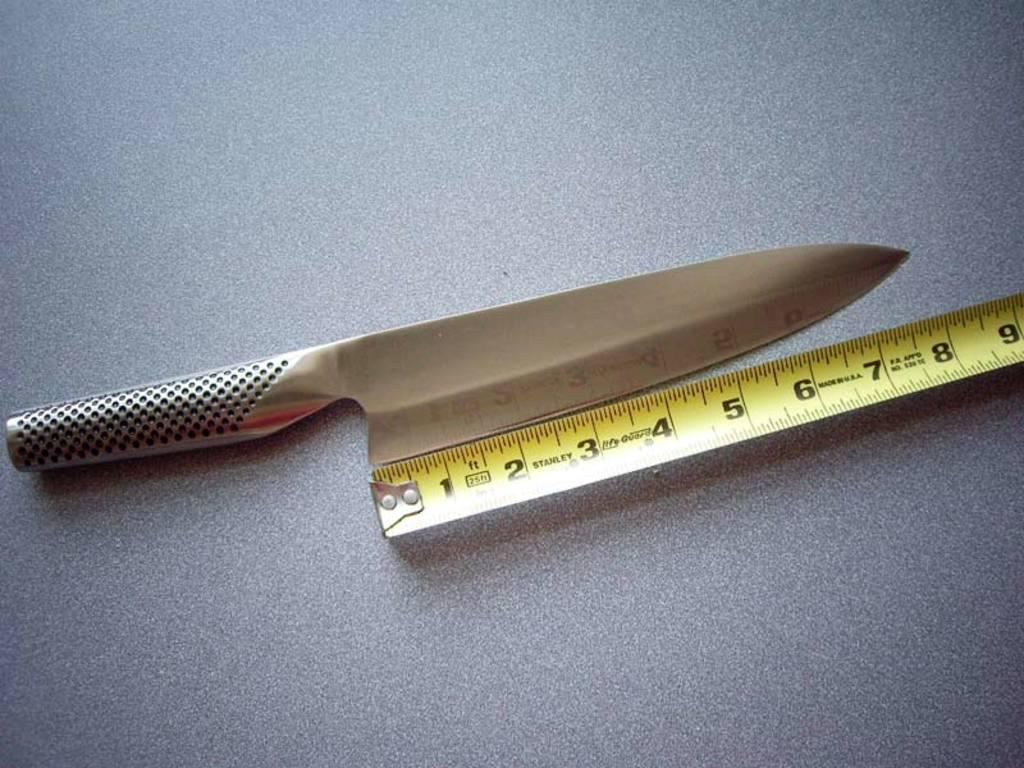What type of tool is visible in the image? There is a knife in the image. What other tool can be seen in the image? There is a measuring tape in the image. What type of jeans is being rolled up in the image? There are no jeans present in the image; it only features a knife and a measuring tape. 